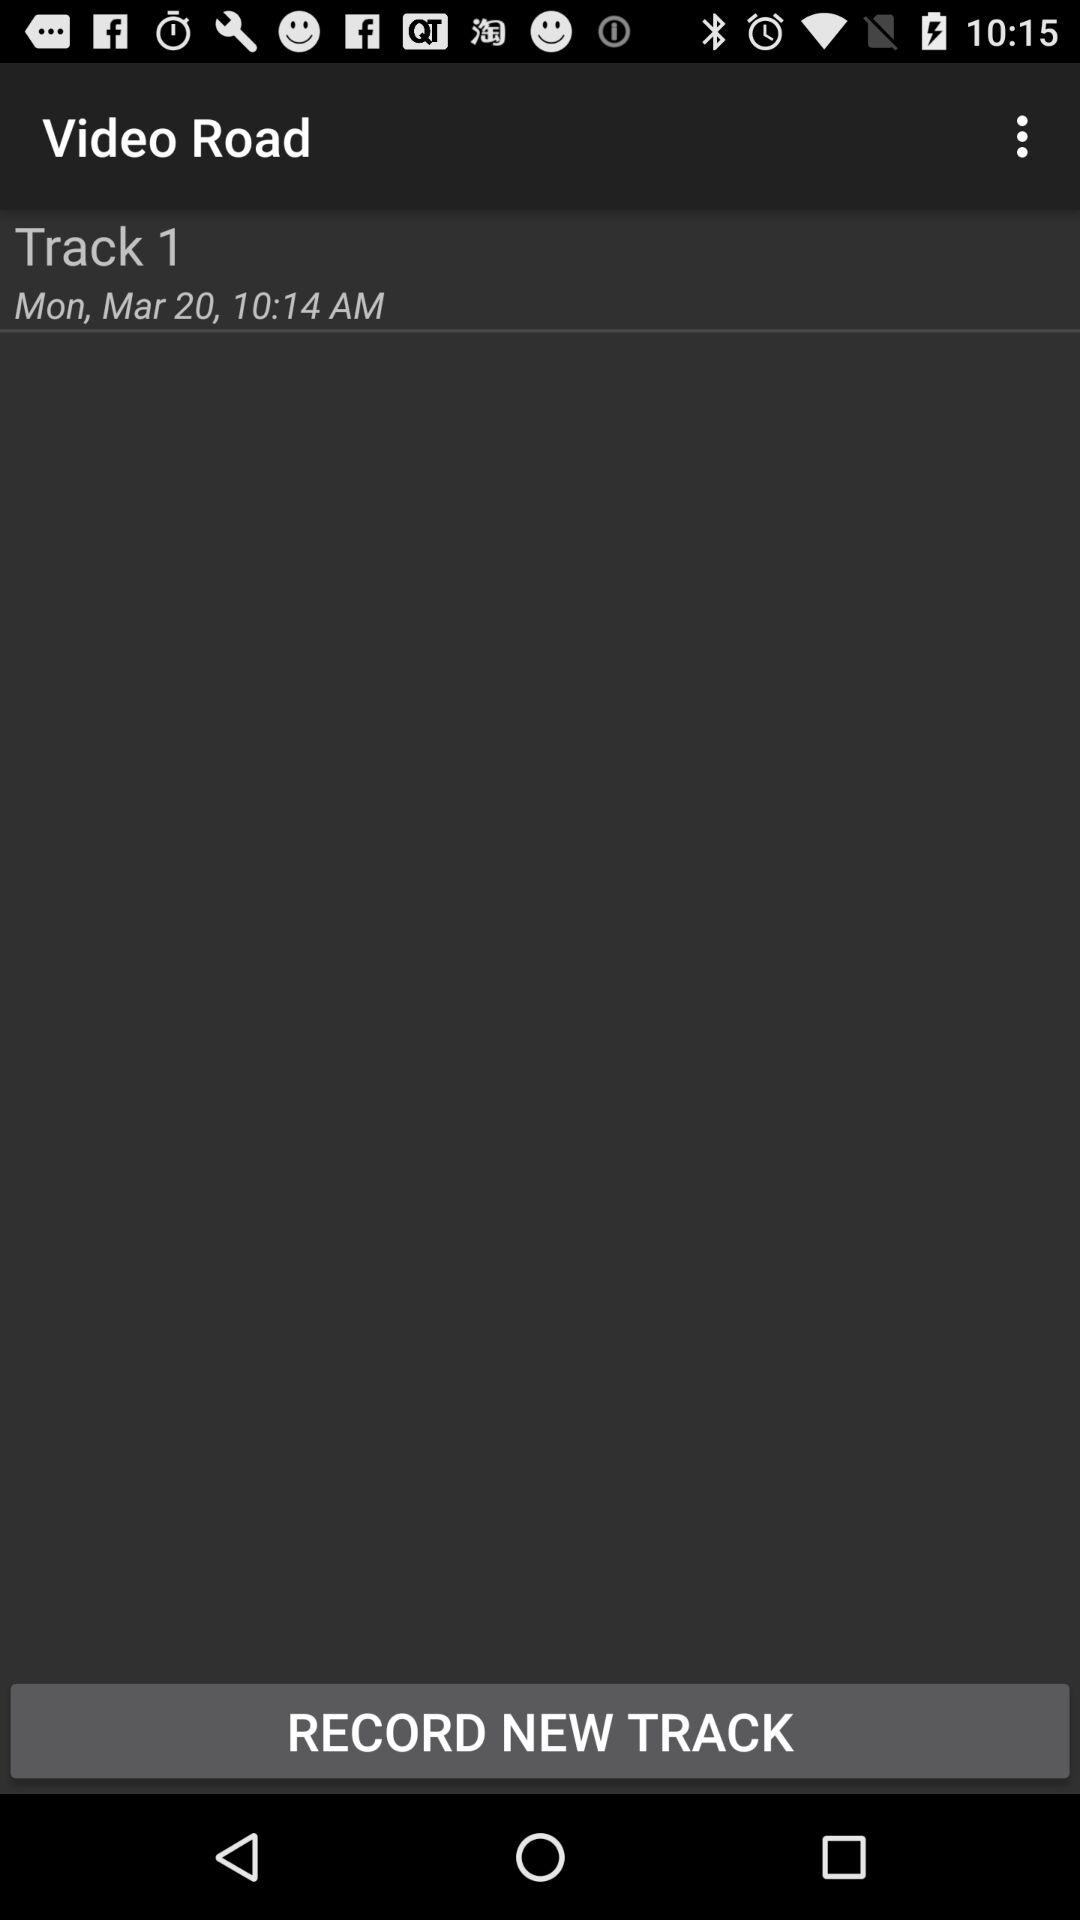On what date was "Track 1" recorded? "Track 1" was recorded on Monday, March 20. 